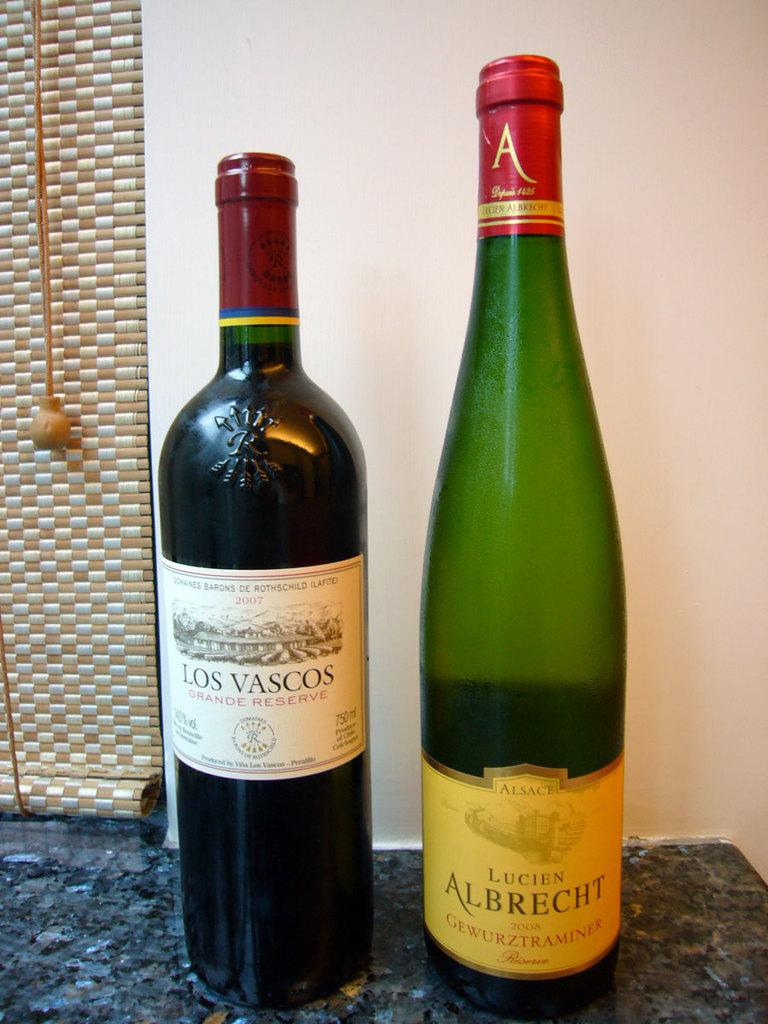What can be seen on the table in the image? There are two wine bottles on the table. What is visible in the background of the image? There is a wall and a curtain in the background of the image. Can you see a turkey in the image? No, there is no turkey present in the image. What type of spoon is being used to serve the wine in the image? There is no spoon visible in the image, as it only shows two wine bottles on the table. 